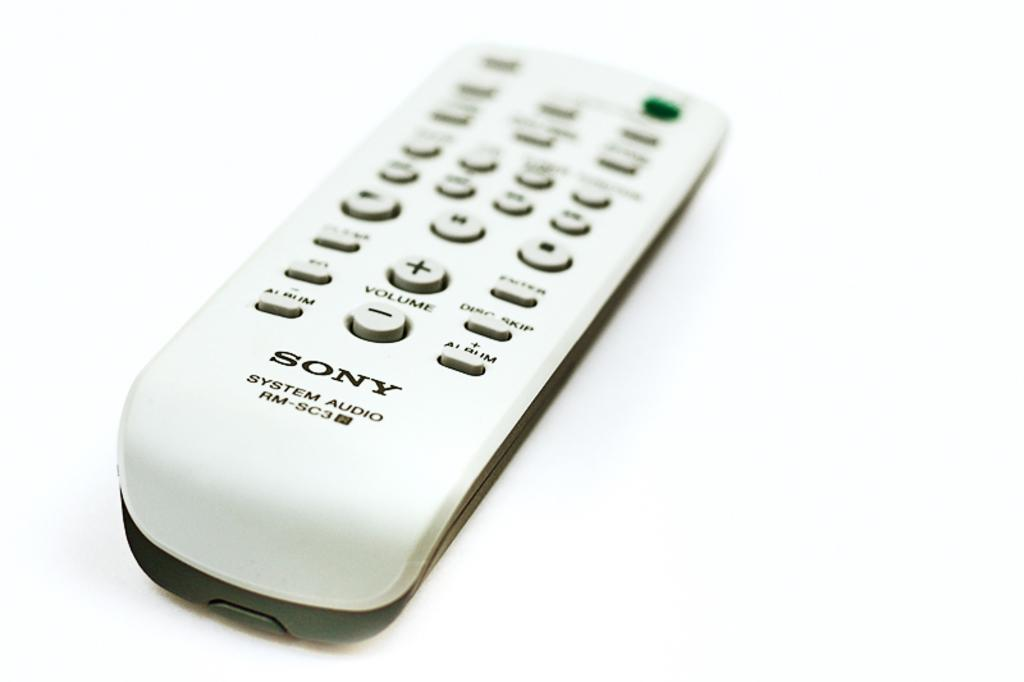Provide a one-sentence caption for the provided image. White Sony controller in front of a white background. 